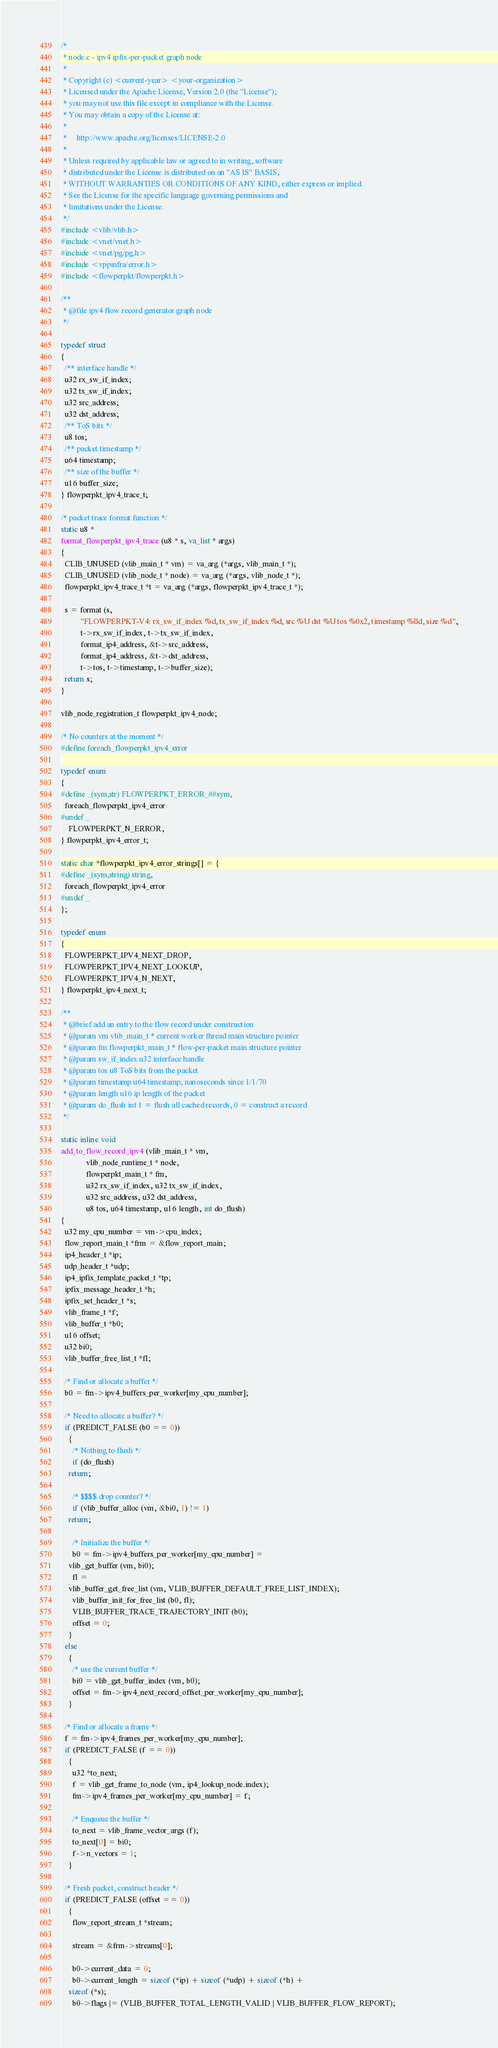<code> <loc_0><loc_0><loc_500><loc_500><_C_>/*
 * node.c - ipv4 ipfix-per-packet graph node
 *
 * Copyright (c) <current-year> <your-organization>
 * Licensed under the Apache License, Version 2.0 (the "License");
 * you may not use this file except in compliance with the License.
 * You may obtain a copy of the License at:
 *
 *     http://www.apache.org/licenses/LICENSE-2.0
 *
 * Unless required by applicable law or agreed to in writing, software
 * distributed under the License is distributed on an "AS IS" BASIS,
 * WITHOUT WARRANTIES OR CONDITIONS OF ANY KIND, either express or implied.
 * See the License for the specific language governing permissions and
 * limitations under the License.
 */
#include <vlib/vlib.h>
#include <vnet/vnet.h>
#include <vnet/pg/pg.h>
#include <vppinfra/error.h>
#include <flowperpkt/flowperpkt.h>

/**
 * @file ipv4 flow record generator graph node
 */

typedef struct
{
  /** interface handle */
  u32 rx_sw_if_index;
  u32 tx_sw_if_index;
  u32 src_address;
  u32 dst_address;
  /** ToS bits */
  u8 tos;
  /** packet timestamp */
  u64 timestamp;
  /** size of the buffer */
  u16 buffer_size;
} flowperpkt_ipv4_trace_t;

/* packet trace format function */
static u8 *
format_flowperpkt_ipv4_trace (u8 * s, va_list * args)
{
  CLIB_UNUSED (vlib_main_t * vm) = va_arg (*args, vlib_main_t *);
  CLIB_UNUSED (vlib_node_t * node) = va_arg (*args, vlib_node_t *);
  flowperpkt_ipv4_trace_t *t = va_arg (*args, flowperpkt_ipv4_trace_t *);

  s = format (s,
	      "FLOWPERPKT-V4: rx_sw_if_index %d, tx_sw_if_index %d, src %U dst %U tos %0x2, timestamp %lld, size %d",
	      t->rx_sw_if_index, t->tx_sw_if_index,
	      format_ip4_address, &t->src_address,
	      format_ip4_address, &t->dst_address,
	      t->tos, t->timestamp, t->buffer_size);
  return s;
}

vlib_node_registration_t flowperpkt_ipv4_node;

/* No counters at the moment */
#define foreach_flowperpkt_ipv4_error

typedef enum
{
#define _(sym,str) FLOWPERPKT_ERROR_##sym,
  foreach_flowperpkt_ipv4_error
#undef _
    FLOWPERPKT_N_ERROR,
} flowperpkt_ipv4_error_t;

static char *flowperpkt_ipv4_error_strings[] = {
#define _(sym,string) string,
  foreach_flowperpkt_ipv4_error
#undef _
};

typedef enum
{
  FLOWPERPKT_IPV4_NEXT_DROP,
  FLOWPERPKT_IPV4_NEXT_LOOKUP,
  FLOWPERPKT_IPV4_N_NEXT,
} flowperpkt_ipv4_next_t;

/**
 * @brief add an entry to the flow record under construction
 * @param vm vlib_main_t * current worker thread main structure pointer
 * @param fm flowperpkt_main_t * flow-per-packet main structure pointer
 * @param sw_if_index u32 interface handle
 * @param tos u8 ToS bits from the packet
 * @param timestamp u64 timestamp, nanoseconds since 1/1/70
 * @param length u16 ip length of the packet
 * @param do_flush int 1 = flush all cached records, 0 = construct a record
 */

static inline void
add_to_flow_record_ipv4 (vlib_main_t * vm,
			 vlib_node_runtime_t * node,
			 flowperpkt_main_t * fm,
			 u32 rx_sw_if_index, u32 tx_sw_if_index,
			 u32 src_address, u32 dst_address,
			 u8 tos, u64 timestamp, u16 length, int do_flush)
{
  u32 my_cpu_number = vm->cpu_index;
  flow_report_main_t *frm = &flow_report_main;
  ip4_header_t *ip;
  udp_header_t *udp;
  ip4_ipfix_template_packet_t *tp;
  ipfix_message_header_t *h;
  ipfix_set_header_t *s;
  vlib_frame_t *f;
  vlib_buffer_t *b0;
  u16 offset;
  u32 bi0;
  vlib_buffer_free_list_t *fl;

  /* Find or allocate a buffer */
  b0 = fm->ipv4_buffers_per_worker[my_cpu_number];

  /* Need to allocate a buffer? */
  if (PREDICT_FALSE (b0 == 0))
    {
      /* Nothing to flush */
      if (do_flush)
	return;

      /* $$$$ drop counter? */
      if (vlib_buffer_alloc (vm, &bi0, 1) != 1)
	return;

      /* Initialize the buffer */
      b0 = fm->ipv4_buffers_per_worker[my_cpu_number] =
	vlib_get_buffer (vm, bi0);
      fl =
	vlib_buffer_get_free_list (vm, VLIB_BUFFER_DEFAULT_FREE_LIST_INDEX);
      vlib_buffer_init_for_free_list (b0, fl);
      VLIB_BUFFER_TRACE_TRAJECTORY_INIT (b0);
      offset = 0;
    }
  else
    {
      /* use the current buffer */
      bi0 = vlib_get_buffer_index (vm, b0);
      offset = fm->ipv4_next_record_offset_per_worker[my_cpu_number];
    }

  /* Find or allocate a frame */
  f = fm->ipv4_frames_per_worker[my_cpu_number];
  if (PREDICT_FALSE (f == 0))
    {
      u32 *to_next;
      f = vlib_get_frame_to_node (vm, ip4_lookup_node.index);
      fm->ipv4_frames_per_worker[my_cpu_number] = f;

      /* Enqueue the buffer */
      to_next = vlib_frame_vector_args (f);
      to_next[0] = bi0;
      f->n_vectors = 1;
    }

  /* Fresh packet, construct header */
  if (PREDICT_FALSE (offset == 0))
    {
      flow_report_stream_t *stream;

      stream = &frm->streams[0];

      b0->current_data = 0;
      b0->current_length = sizeof (*ip) + sizeof (*udp) + sizeof (*h) +
	sizeof (*s);
      b0->flags |= (VLIB_BUFFER_TOTAL_LENGTH_VALID | VLIB_BUFFER_FLOW_REPORT);</code> 